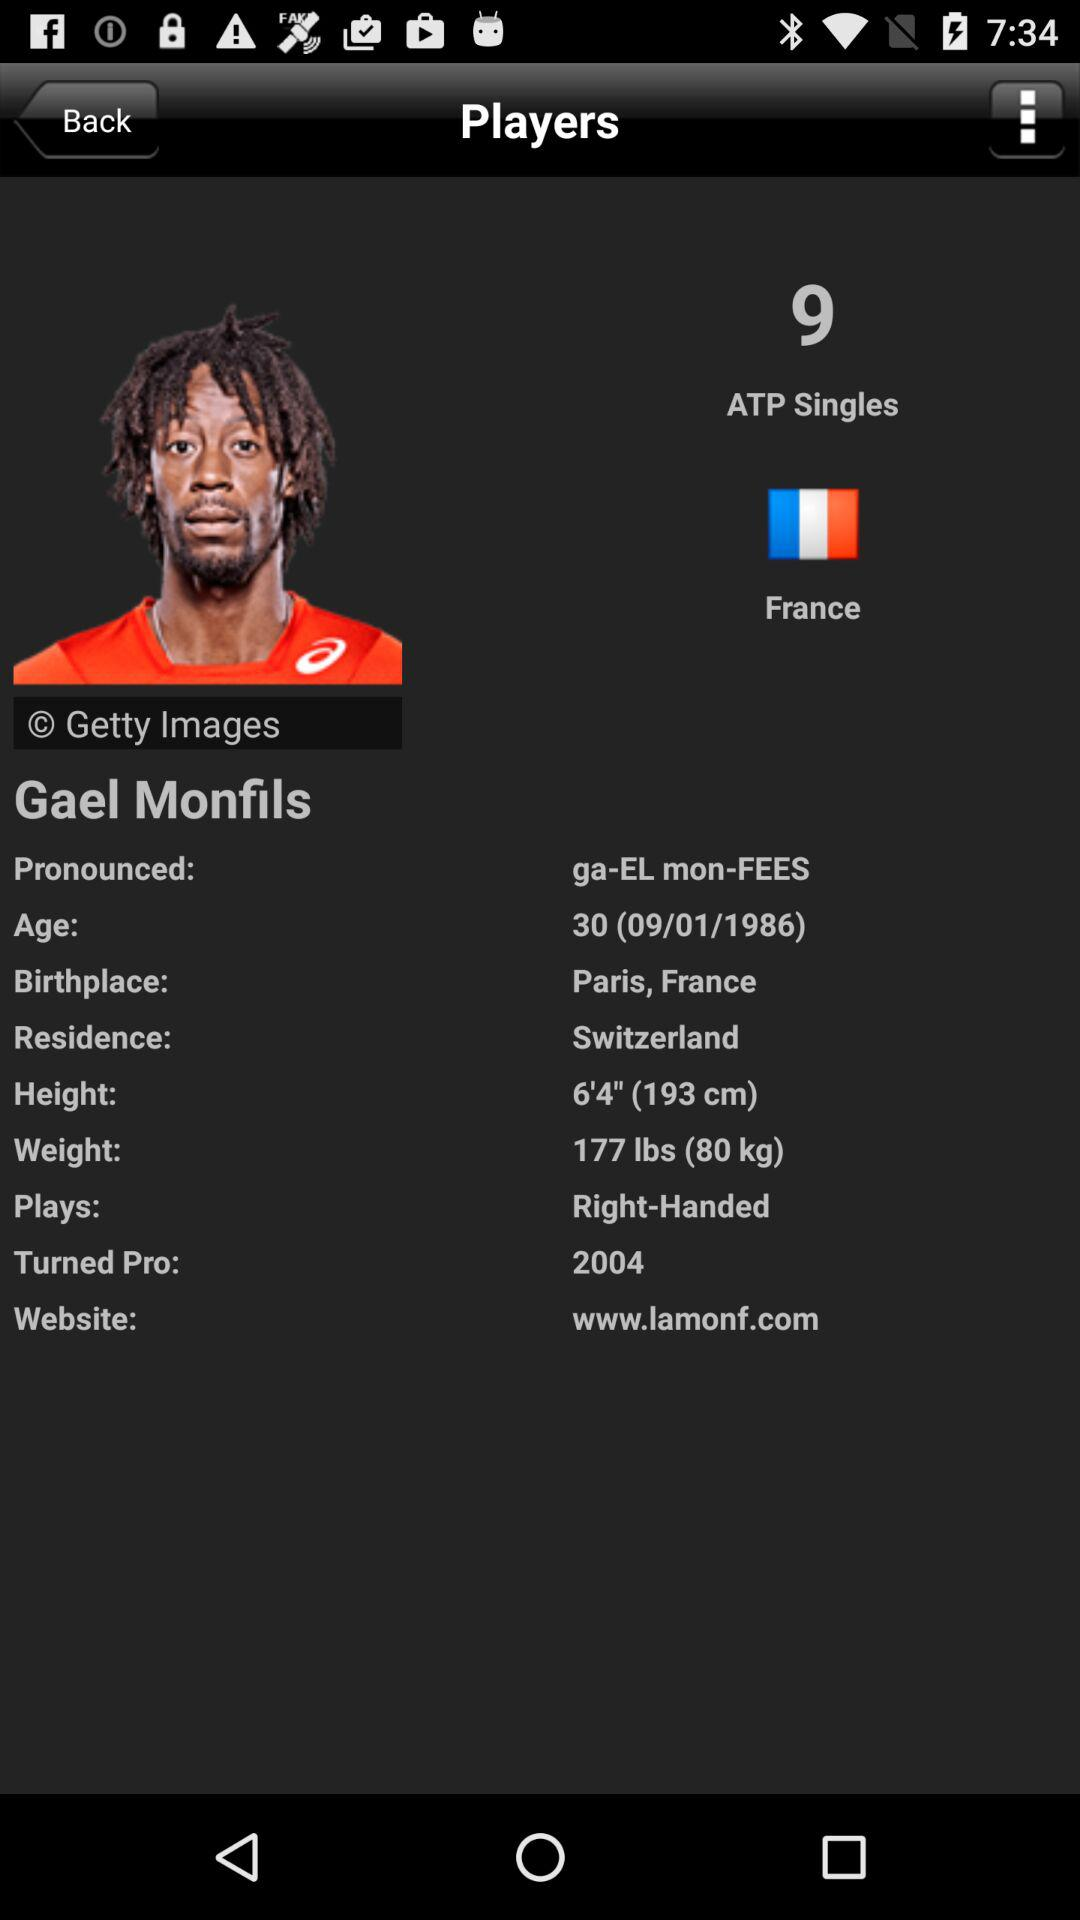What is the name of the player? The name of the player is Gael Monfils. 